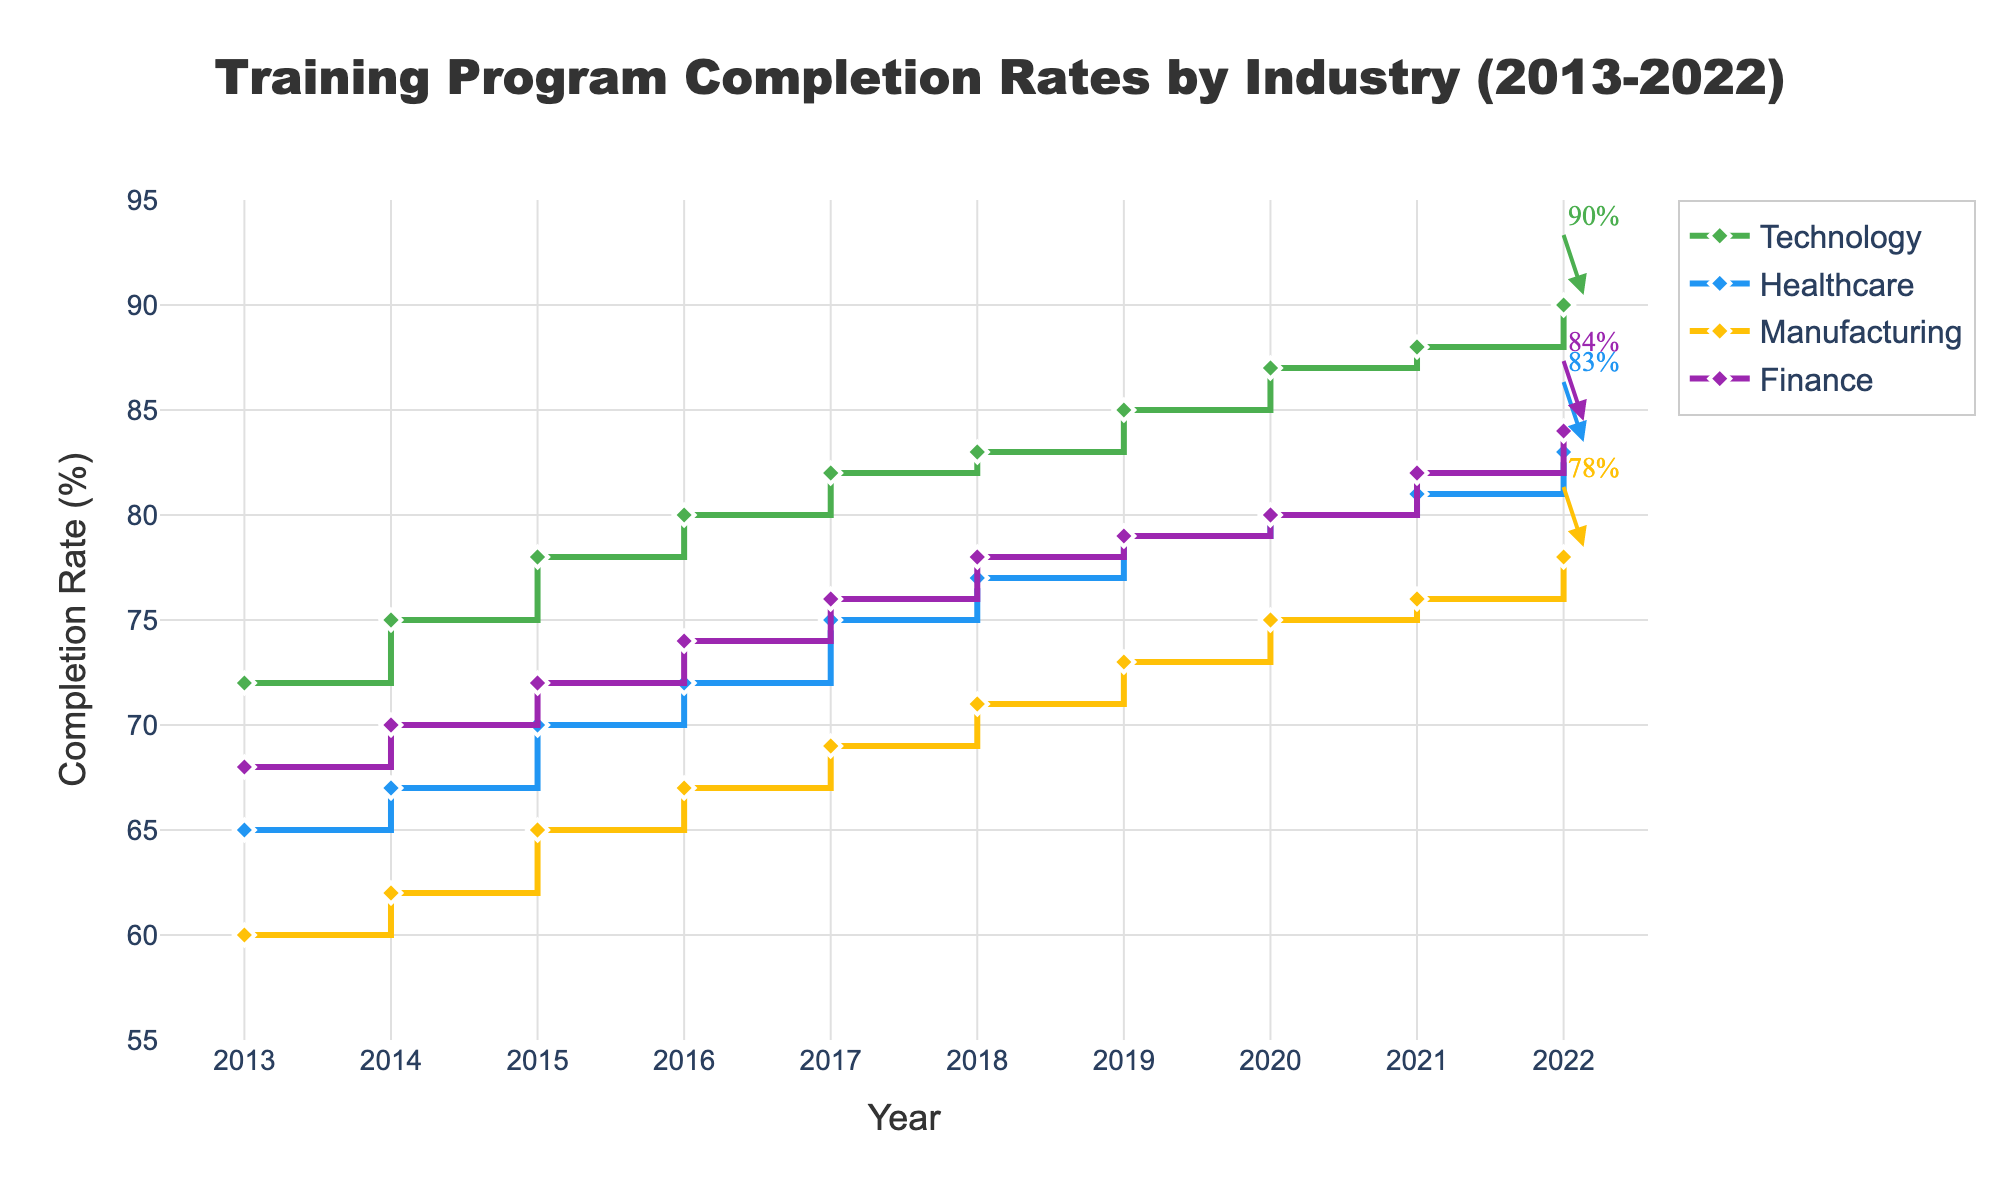What's the title of the figure? The title is usually displayed at the top of the figure and gives an overview of the data shown. In this case, the title reads "Training Program Completion Rates by Industry (2013-2022)."
Answer: Training Program Completion Rates by Industry (2013-2022) How many industries are shown in the plot? By looking at the legend in the plot, we can count the different categories listed. Here, the legend shows four distinct industries: Technology, Healthcare, Manufacturing, and Finance.
Answer: 4 Which industry had the highest completion rate in 2022? To find this, we look at the data points for the year 2022 across all industries and identify which one has the highest value on the Y-axis. Technology has the highest completion rate of 90% in 2022.
Answer: Technology What is the completion rate for Healthcare in 2015? Locate the point on the plot corresponding to the Healthcare industry and the year 2015. The Y-axis value at this point is 70%.
Answer: 70% Calculate the difference in completion rates between Healthcare and Manufacturing in 2019. Find the completion rate for Healthcare and Manufacturing in 2019. Healthcare is at 79% and Manufacturing is at 73%. Subtract 73 from 79 to get the difference.
Answer: 6% Which industry shows the most improvement in completion rates from 2013 to 2022? Calculate the difference in completion rates between 2022 and 2013 for each industry and compare. Technology improved by 18%, Healthcare by 18%, Manufacturing by 18%, and Finance by 16%. However, they all seem to show the same improvement.
Answer: Technology, Healthcare, Manufacturing What is the range of completion rates in the Finance industry from 2013 to 2022? To find the range, subtract the minimum completion rate from the maximum completion rate within the Finance industry over these years. The range is 84% - 68%.
Answer: 16% How does the completion rate trend for Manufacturing compare to that of Technology? Both trends can be observed by following the line plots for Manufacturing and Technology. Technology shows a consistent upward trend, while Manufacturing does so as well, but at a slightly lower rate. Both industries' trend lines consistently slope upwards.
Answer: Both show an upward trend, but Technology has higher rates Which industry had the lowest completion rate in 2020? Look at the data points for the year 2020 for each industry and identify the industry with the lowest value on the Y-axis. Manufacturing had the lowest completion rate of 75% in 2020.
Answer: Manufacturing 